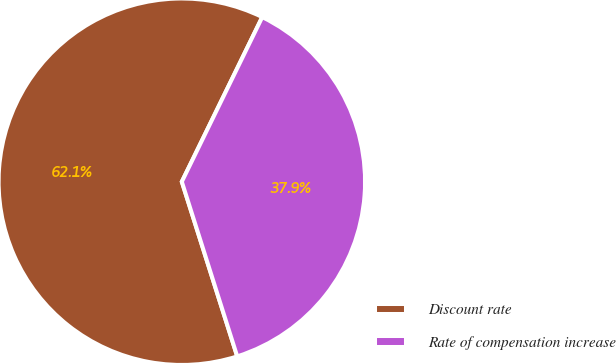Convert chart. <chart><loc_0><loc_0><loc_500><loc_500><pie_chart><fcel>Discount rate<fcel>Rate of compensation increase<nl><fcel>62.12%<fcel>37.88%<nl></chart> 